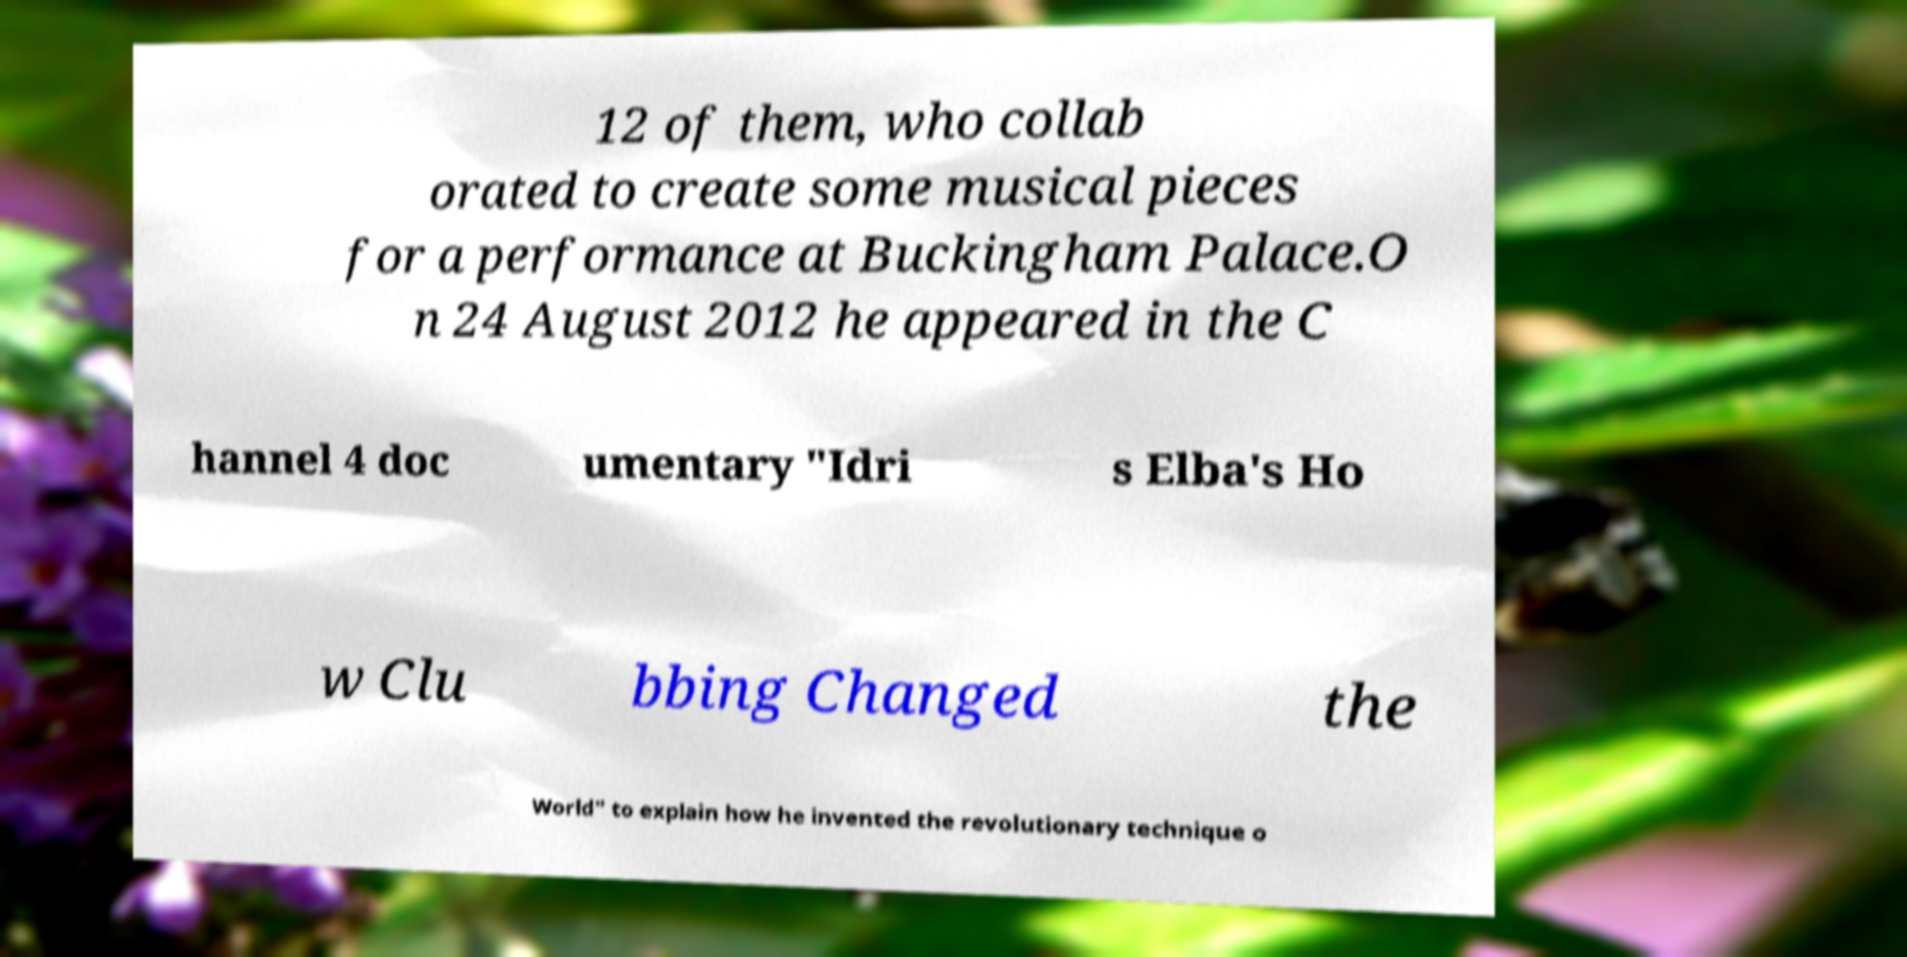Could you extract and type out the text from this image? 12 of them, who collab orated to create some musical pieces for a performance at Buckingham Palace.O n 24 August 2012 he appeared in the C hannel 4 doc umentary "Idri s Elba's Ho w Clu bbing Changed the World" to explain how he invented the revolutionary technique o 